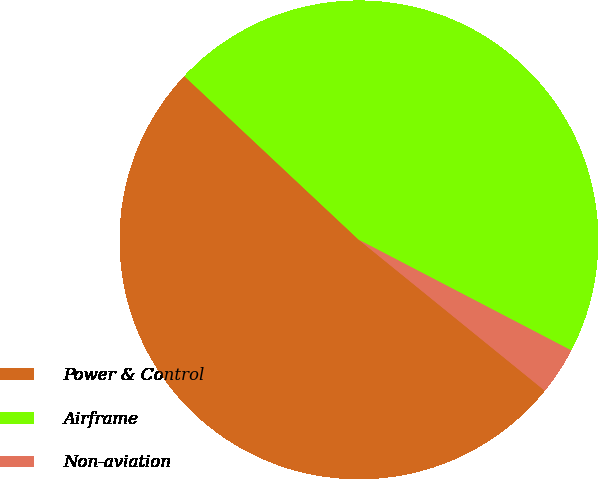<chart> <loc_0><loc_0><loc_500><loc_500><pie_chart><fcel>Power & Control<fcel>Airframe<fcel>Non-aviation<nl><fcel>51.14%<fcel>45.65%<fcel>3.21%<nl></chart> 